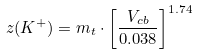Convert formula to latex. <formula><loc_0><loc_0><loc_500><loc_500>z ( K ^ { + } ) = m _ { t } \cdot \left [ \frac { V _ { c b } } { 0 . 0 3 8 } \right ] ^ { 1 . 7 4 }</formula> 